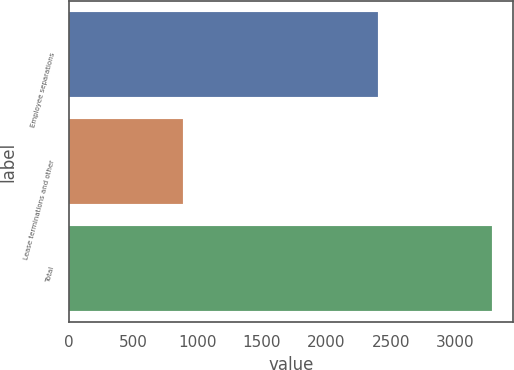<chart> <loc_0><loc_0><loc_500><loc_500><bar_chart><fcel>Employee separations<fcel>Lease terminations and other<fcel>Total<nl><fcel>2397<fcel>888<fcel>3285<nl></chart> 